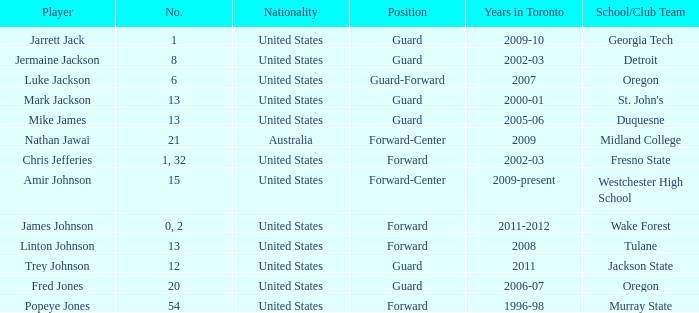What are the nationality of the players on the Fresno State school/club team? United States. 